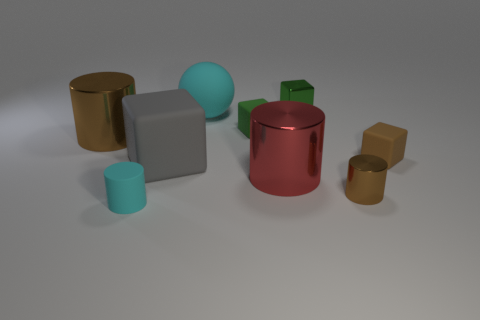Subtract all green blocks. How many were subtracted if there are1green blocks left? 1 Subtract all cubes. How many objects are left? 5 Subtract all tiny matte cylinders. How many cylinders are left? 3 Subtract 3 cylinders. How many cylinders are left? 1 Subtract all blue spheres. Subtract all red cubes. How many spheres are left? 1 Subtract all green cubes. How many gray cylinders are left? 0 Subtract all shiny objects. Subtract all red shiny objects. How many objects are left? 4 Add 1 large gray rubber blocks. How many large gray rubber blocks are left? 2 Add 5 gray rubber things. How many gray rubber things exist? 6 Add 1 brown metal cylinders. How many objects exist? 10 